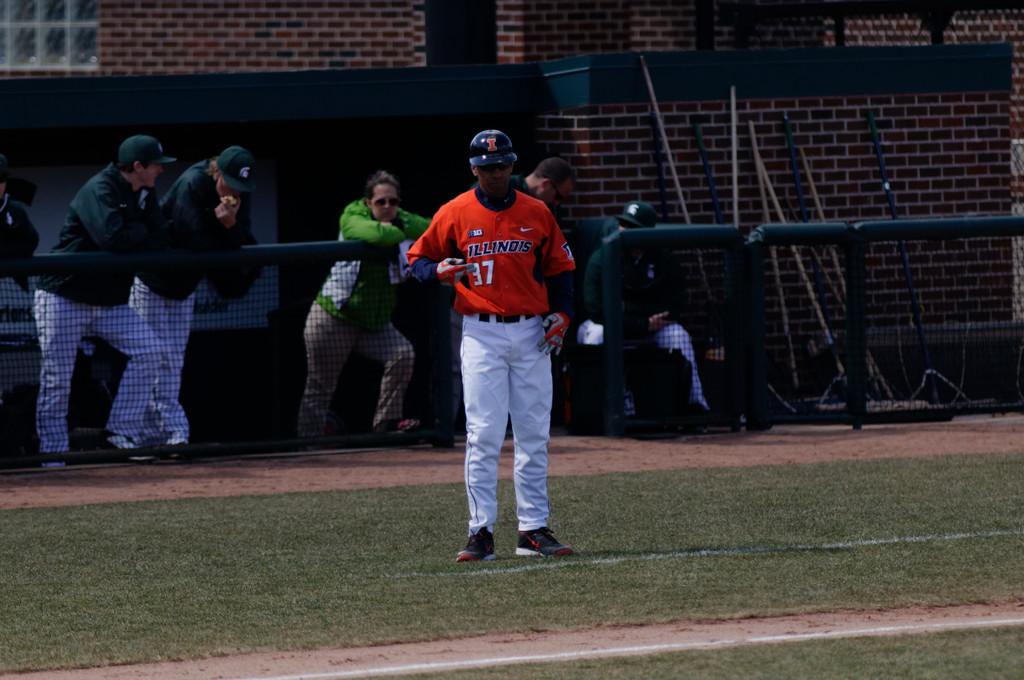What state is the player from?
Give a very brief answer. Illinois. 